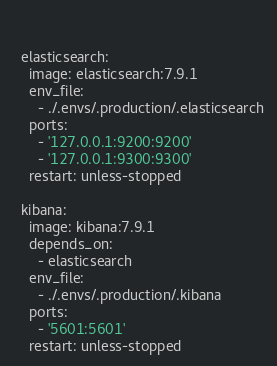<code> <loc_0><loc_0><loc_500><loc_500><_YAML_>  

  elasticsearch:
    image: elasticsearch:7.9.1
    env_file:
      - ./.envs/.production/.elasticsearch
    ports:
      - '127.0.0.1:9200:9200'
      - '127.0.0.1:9300:9300'
    restart: unless-stopped

  kibana:
    image: kibana:7.9.1
    depends_on:
      - elasticsearch
    env_file:
      - ./.envs/.production/.kibana
    ports:
      - '5601:5601'
    restart: unless-stopped
</code> 